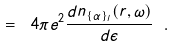<formula> <loc_0><loc_0><loc_500><loc_500>= \ 4 \pi e ^ { 2 } \frac { d n _ { \{ \alpha \} _ { l } } ( { r } , \omega ) } { d \epsilon } \ .</formula> 